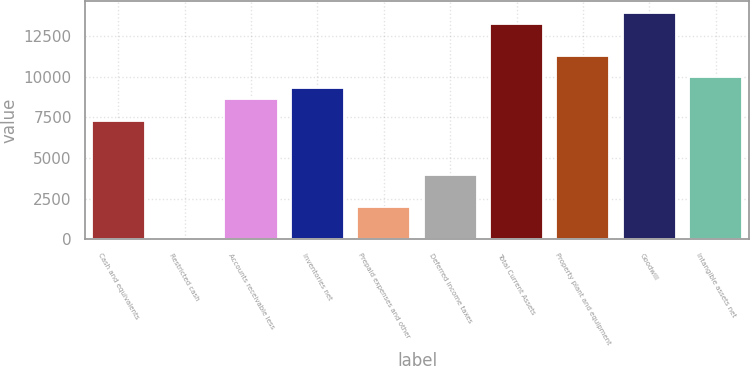<chart> <loc_0><loc_0><loc_500><loc_500><bar_chart><fcel>Cash and equivalents<fcel>Restricted cash<fcel>Accounts receivable less<fcel>Inventories net<fcel>Prepaid expenses and other<fcel>Deferred income taxes<fcel>Total Current Assets<fcel>Property plant and equipment<fcel>Goodwill<fcel>Intangible assets net<nl><fcel>7296.82<fcel>2.5<fcel>8623.06<fcel>9286.18<fcel>1991.86<fcel>3981.22<fcel>13264.9<fcel>11275.5<fcel>13928<fcel>9949.3<nl></chart> 